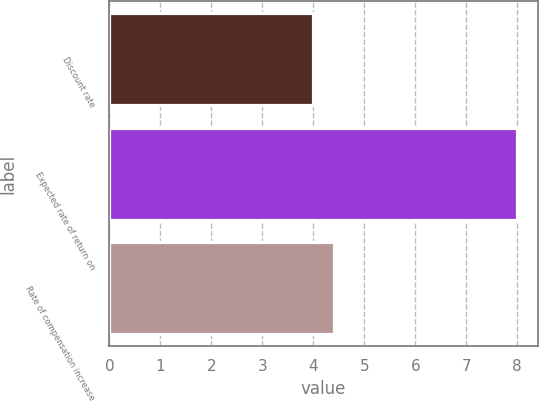Convert chart to OTSL. <chart><loc_0><loc_0><loc_500><loc_500><bar_chart><fcel>Discount rate<fcel>Expected rate of return on<fcel>Rate of compensation increase<nl><fcel>4<fcel>8<fcel>4.4<nl></chart> 